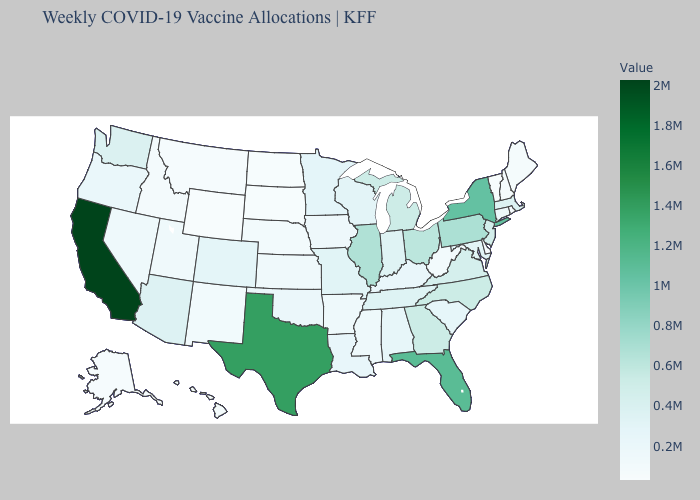Which states have the lowest value in the MidWest?
Concise answer only. North Dakota. Which states have the lowest value in the MidWest?
Be succinct. North Dakota. Which states have the highest value in the USA?
Concise answer only. California. Which states have the lowest value in the West?
Answer briefly. Wyoming. Does Wyoming have the lowest value in the USA?
Write a very short answer. Yes. Does Illinois have the highest value in the MidWest?
Keep it brief. Yes. 